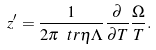<formula> <loc_0><loc_0><loc_500><loc_500>z ^ { \prime } = \frac { 1 } { 2 \pi \ t r \eta \Lambda } \frac { \partial } { \partial T } \frac { \Omega } { T } .</formula> 